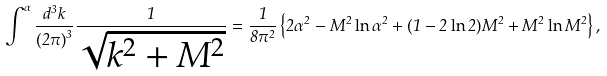Convert formula to latex. <formula><loc_0><loc_0><loc_500><loc_500>\int ^ { \alpha } \frac { d ^ { 3 } k } { { ( 2 \pi ) } ^ { 3 } } \frac { 1 } { \sqrt { k ^ { 2 } + M ^ { 2 } } } = \frac { 1 } { 8 \pi ^ { 2 } } \left \{ 2 \alpha ^ { 2 } - M ^ { 2 } \ln \alpha ^ { 2 } + ( 1 - 2 \ln 2 ) M ^ { 2 } + M ^ { 2 } \ln M ^ { 2 } \right \} ,</formula> 